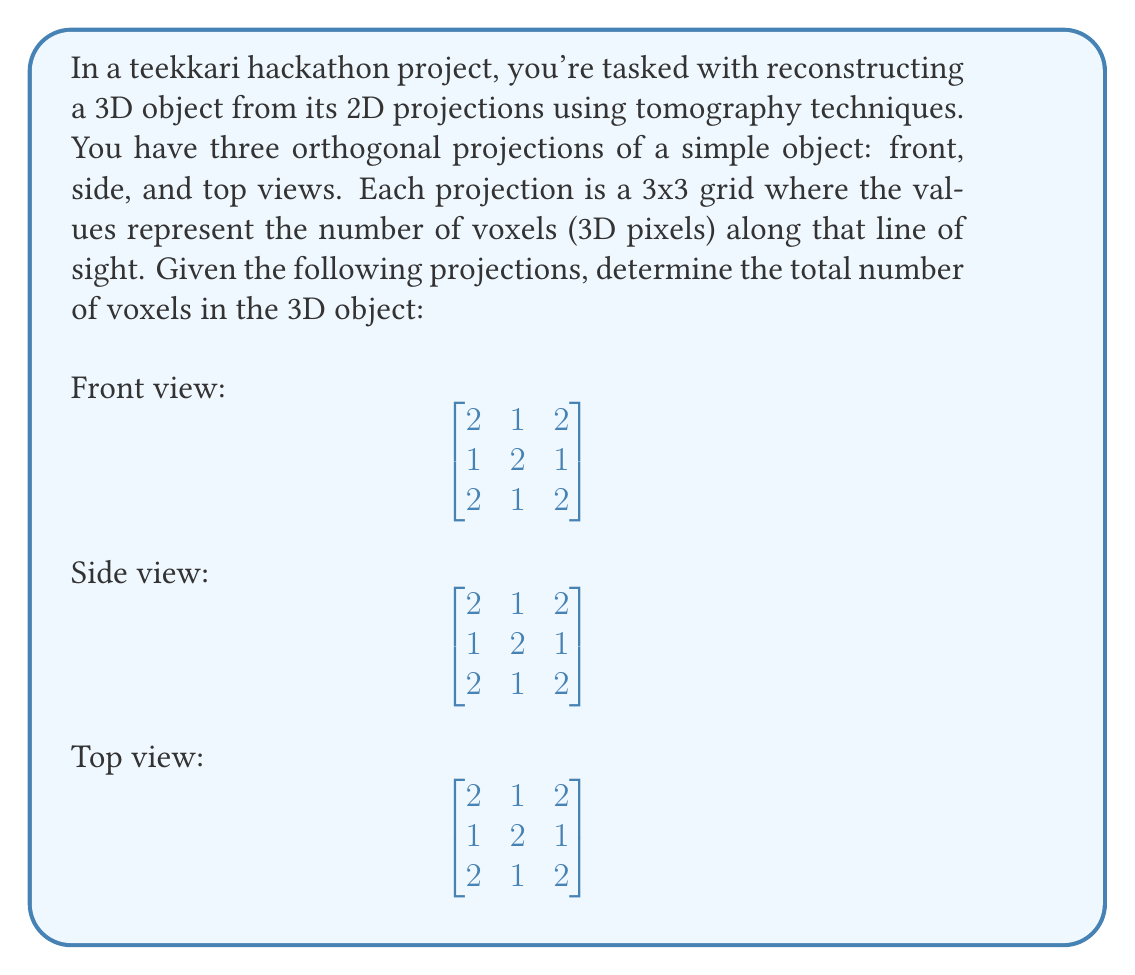Show me your answer to this math problem. To solve this problem, we'll use the Algebraic Reconstruction Technique (ART), a common method in tomography. Let's approach this step-by-step:

1) First, we need to understand what these projections mean. Each number in the projection represents the sum of voxels along that line of sight.

2) We can represent our 3D object as a 3x3x3 cube, with each cell containing either 0 or 1 voxel. Let's call these cells $x_{ijk}$ where $i$, $j$, and $k$ are the coordinates in the 3D space.

3) From the front view, we can deduce:
   $$x_{111} + x_{112} + x_{113} = 2$$
   $$x_{121} + x_{122} + x_{123} = 1$$
   $$x_{131} + x_{132} + x_{133} = 2$$
   ... and so on for each row and column.

4) We can write similar equations for the side and top views.

5) Given the symmetry of the projections, we can deduce that the object must have some form of symmetry as well.

6) The central voxel ($x_{222}$) must be 1, as it's the only way to satisfy the central 2 in all projections.

7) The corner voxels ($x_{111}$, $x_{113}$, $x_{131}$, $x_{133}$, $x_{311}$, $x_{313}$, $x_{331}$, $x_{333}$) must all be 1 to satisfy the 2's in the corners of all projections.

8) The remaining voxels must be 0 to satisfy the 1's in the projections.

9) Therefore, the 3D object looks like this:
   [asy]
   import three;
   size(200);
   currentprojection=perspective(6,3,2);
   draw(unitcube,opacity(0.1));
   dot((0,0,0),red); dot((0,0,1),red); dot((0,1,0),red); dot((0,1,1),red);
   dot((1,0,0),red); dot((1,0,1),red); dot((1,1,0),red); dot((1,1,1),red);
   dot((0.5,0.5,0.5),red);
   [/asy]

10) Counting the red dots, we can see that there are 9 voxels in total.
Answer: 9 voxels 